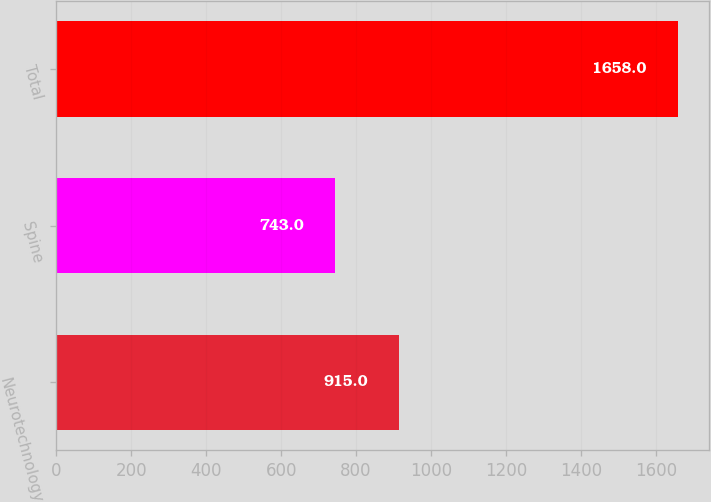Convert chart. <chart><loc_0><loc_0><loc_500><loc_500><bar_chart><fcel>Neurotechnology<fcel>Spine<fcel>Total<nl><fcel>915<fcel>743<fcel>1658<nl></chart> 